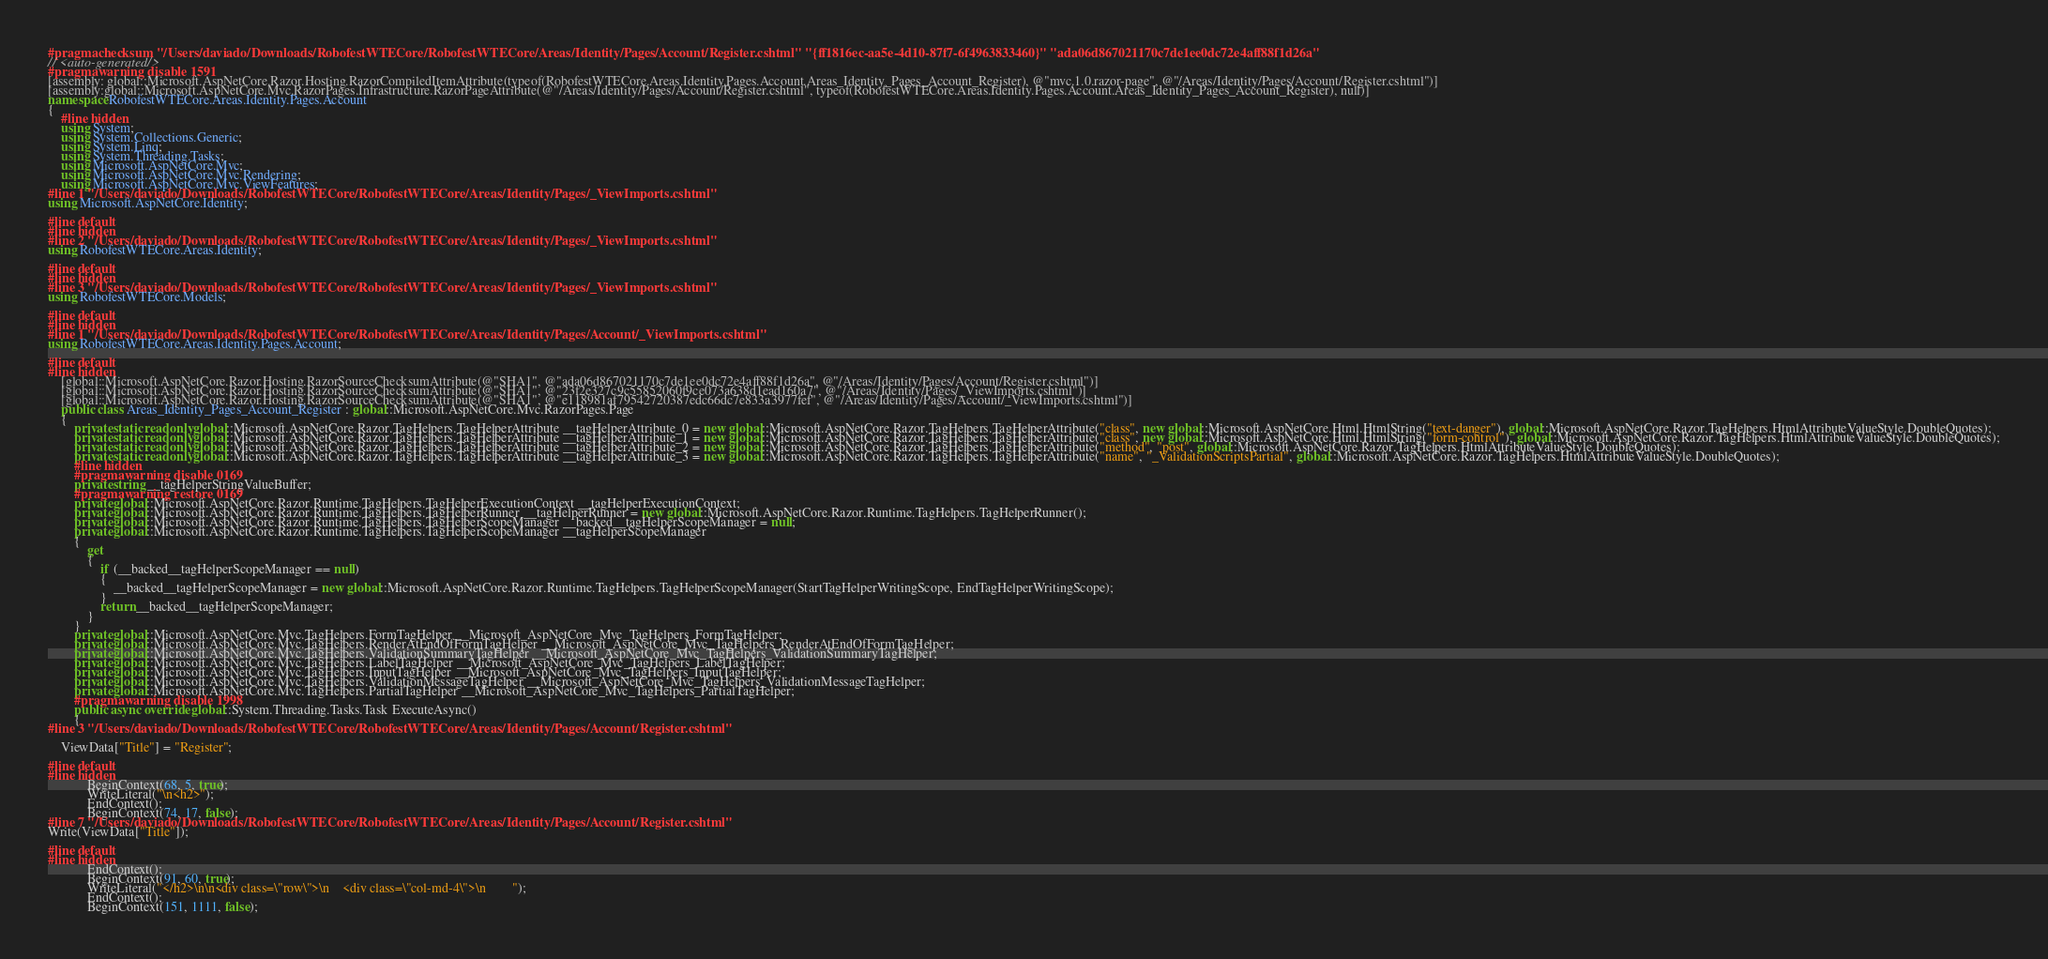Convert code to text. <code><loc_0><loc_0><loc_500><loc_500><_C#_>#pragma checksum "/Users/daviado/Downloads/RobofestWTECore/RobofestWTECore/Areas/Identity/Pages/Account/Register.cshtml" "{ff1816ec-aa5e-4d10-87f7-6f4963833460}" "ada06d867021170c7de1ee0dc72e4aff88f1d26a"
// <auto-generated/>
#pragma warning disable 1591
[assembly: global::Microsoft.AspNetCore.Razor.Hosting.RazorCompiledItemAttribute(typeof(RobofestWTECore.Areas.Identity.Pages.Account.Areas_Identity_Pages_Account_Register), @"mvc.1.0.razor-page", @"/Areas/Identity/Pages/Account/Register.cshtml")]
[assembly:global::Microsoft.AspNetCore.Mvc.RazorPages.Infrastructure.RazorPageAttribute(@"/Areas/Identity/Pages/Account/Register.cshtml", typeof(RobofestWTECore.Areas.Identity.Pages.Account.Areas_Identity_Pages_Account_Register), null)]
namespace RobofestWTECore.Areas.Identity.Pages.Account
{
    #line hidden
    using System;
    using System.Collections.Generic;
    using System.Linq;
    using System.Threading.Tasks;
    using Microsoft.AspNetCore.Mvc;
    using Microsoft.AspNetCore.Mvc.Rendering;
    using Microsoft.AspNetCore.Mvc.ViewFeatures;
#line 1 "/Users/daviado/Downloads/RobofestWTECore/RobofestWTECore/Areas/Identity/Pages/_ViewImports.cshtml"
using Microsoft.AspNetCore.Identity;

#line default
#line hidden
#line 2 "/Users/daviado/Downloads/RobofestWTECore/RobofestWTECore/Areas/Identity/Pages/_ViewImports.cshtml"
using RobofestWTECore.Areas.Identity;

#line default
#line hidden
#line 3 "/Users/daviado/Downloads/RobofestWTECore/RobofestWTECore/Areas/Identity/Pages/_ViewImports.cshtml"
using RobofestWTECore.Models;

#line default
#line hidden
#line 1 "/Users/daviado/Downloads/RobofestWTECore/RobofestWTECore/Areas/Identity/Pages/Account/_ViewImports.cshtml"
using RobofestWTECore.Areas.Identity.Pages.Account;

#line default
#line hidden
    [global::Microsoft.AspNetCore.Razor.Hosting.RazorSourceChecksumAttribute(@"SHA1", @"ada06d867021170c7de1ee0dc72e4aff88f1d26a", @"/Areas/Identity/Pages/Account/Register.cshtml")]
    [global::Microsoft.AspNetCore.Razor.Hosting.RazorSourceChecksumAttribute(@"SHA1", @"23f2e327c9c55852060f9ce073a638d1ead160a7", @"/Areas/Identity/Pages/_ViewImports.cshtml")]
    [global::Microsoft.AspNetCore.Razor.Hosting.RazorSourceChecksumAttribute(@"SHA1", @"e118981af79542720387edc66dc7e833a3977fef", @"/Areas/Identity/Pages/Account/_ViewImports.cshtml")]
    public class Areas_Identity_Pages_Account_Register : global::Microsoft.AspNetCore.Mvc.RazorPages.Page
    {
        private static readonly global::Microsoft.AspNetCore.Razor.TagHelpers.TagHelperAttribute __tagHelperAttribute_0 = new global::Microsoft.AspNetCore.Razor.TagHelpers.TagHelperAttribute("class", new global::Microsoft.AspNetCore.Html.HtmlString("text-danger"), global::Microsoft.AspNetCore.Razor.TagHelpers.HtmlAttributeValueStyle.DoubleQuotes);
        private static readonly global::Microsoft.AspNetCore.Razor.TagHelpers.TagHelperAttribute __tagHelperAttribute_1 = new global::Microsoft.AspNetCore.Razor.TagHelpers.TagHelperAttribute("class", new global::Microsoft.AspNetCore.Html.HtmlString("form-control"), global::Microsoft.AspNetCore.Razor.TagHelpers.HtmlAttributeValueStyle.DoubleQuotes);
        private static readonly global::Microsoft.AspNetCore.Razor.TagHelpers.TagHelperAttribute __tagHelperAttribute_2 = new global::Microsoft.AspNetCore.Razor.TagHelpers.TagHelperAttribute("method", "post", global::Microsoft.AspNetCore.Razor.TagHelpers.HtmlAttributeValueStyle.DoubleQuotes);
        private static readonly global::Microsoft.AspNetCore.Razor.TagHelpers.TagHelperAttribute __tagHelperAttribute_3 = new global::Microsoft.AspNetCore.Razor.TagHelpers.TagHelperAttribute("name", "_ValidationScriptsPartial", global::Microsoft.AspNetCore.Razor.TagHelpers.HtmlAttributeValueStyle.DoubleQuotes);
        #line hidden
        #pragma warning disable 0169
        private string __tagHelperStringValueBuffer;
        #pragma warning restore 0169
        private global::Microsoft.AspNetCore.Razor.Runtime.TagHelpers.TagHelperExecutionContext __tagHelperExecutionContext;
        private global::Microsoft.AspNetCore.Razor.Runtime.TagHelpers.TagHelperRunner __tagHelperRunner = new global::Microsoft.AspNetCore.Razor.Runtime.TagHelpers.TagHelperRunner();
        private global::Microsoft.AspNetCore.Razor.Runtime.TagHelpers.TagHelperScopeManager __backed__tagHelperScopeManager = null;
        private global::Microsoft.AspNetCore.Razor.Runtime.TagHelpers.TagHelperScopeManager __tagHelperScopeManager
        {
            get
            {
                if (__backed__tagHelperScopeManager == null)
                {
                    __backed__tagHelperScopeManager = new global::Microsoft.AspNetCore.Razor.Runtime.TagHelpers.TagHelperScopeManager(StartTagHelperWritingScope, EndTagHelperWritingScope);
                }
                return __backed__tagHelperScopeManager;
            }
        }
        private global::Microsoft.AspNetCore.Mvc.TagHelpers.FormTagHelper __Microsoft_AspNetCore_Mvc_TagHelpers_FormTagHelper;
        private global::Microsoft.AspNetCore.Mvc.TagHelpers.RenderAtEndOfFormTagHelper __Microsoft_AspNetCore_Mvc_TagHelpers_RenderAtEndOfFormTagHelper;
        private global::Microsoft.AspNetCore.Mvc.TagHelpers.ValidationSummaryTagHelper __Microsoft_AspNetCore_Mvc_TagHelpers_ValidationSummaryTagHelper;
        private global::Microsoft.AspNetCore.Mvc.TagHelpers.LabelTagHelper __Microsoft_AspNetCore_Mvc_TagHelpers_LabelTagHelper;
        private global::Microsoft.AspNetCore.Mvc.TagHelpers.InputTagHelper __Microsoft_AspNetCore_Mvc_TagHelpers_InputTagHelper;
        private global::Microsoft.AspNetCore.Mvc.TagHelpers.ValidationMessageTagHelper __Microsoft_AspNetCore_Mvc_TagHelpers_ValidationMessageTagHelper;
        private global::Microsoft.AspNetCore.Mvc.TagHelpers.PartialTagHelper __Microsoft_AspNetCore_Mvc_TagHelpers_PartialTagHelper;
        #pragma warning disable 1998
        public async override global::System.Threading.Tasks.Task ExecuteAsync()
        {
#line 3 "/Users/daviado/Downloads/RobofestWTECore/RobofestWTECore/Areas/Identity/Pages/Account/Register.cshtml"
  
    ViewData["Title"] = "Register";

#line default
#line hidden
            BeginContext(68, 5, true);
            WriteLiteral("\n<h2>");
            EndContext();
            BeginContext(74, 17, false);
#line 7 "/Users/daviado/Downloads/RobofestWTECore/RobofestWTECore/Areas/Identity/Pages/Account/Register.cshtml"
Write(ViewData["Title"]);

#line default
#line hidden
            EndContext();
            BeginContext(91, 60, true);
            WriteLiteral("</h2>\n\n<div class=\"row\">\n    <div class=\"col-md-4\">\n        ");
            EndContext();
            BeginContext(151, 1111, false);</code> 